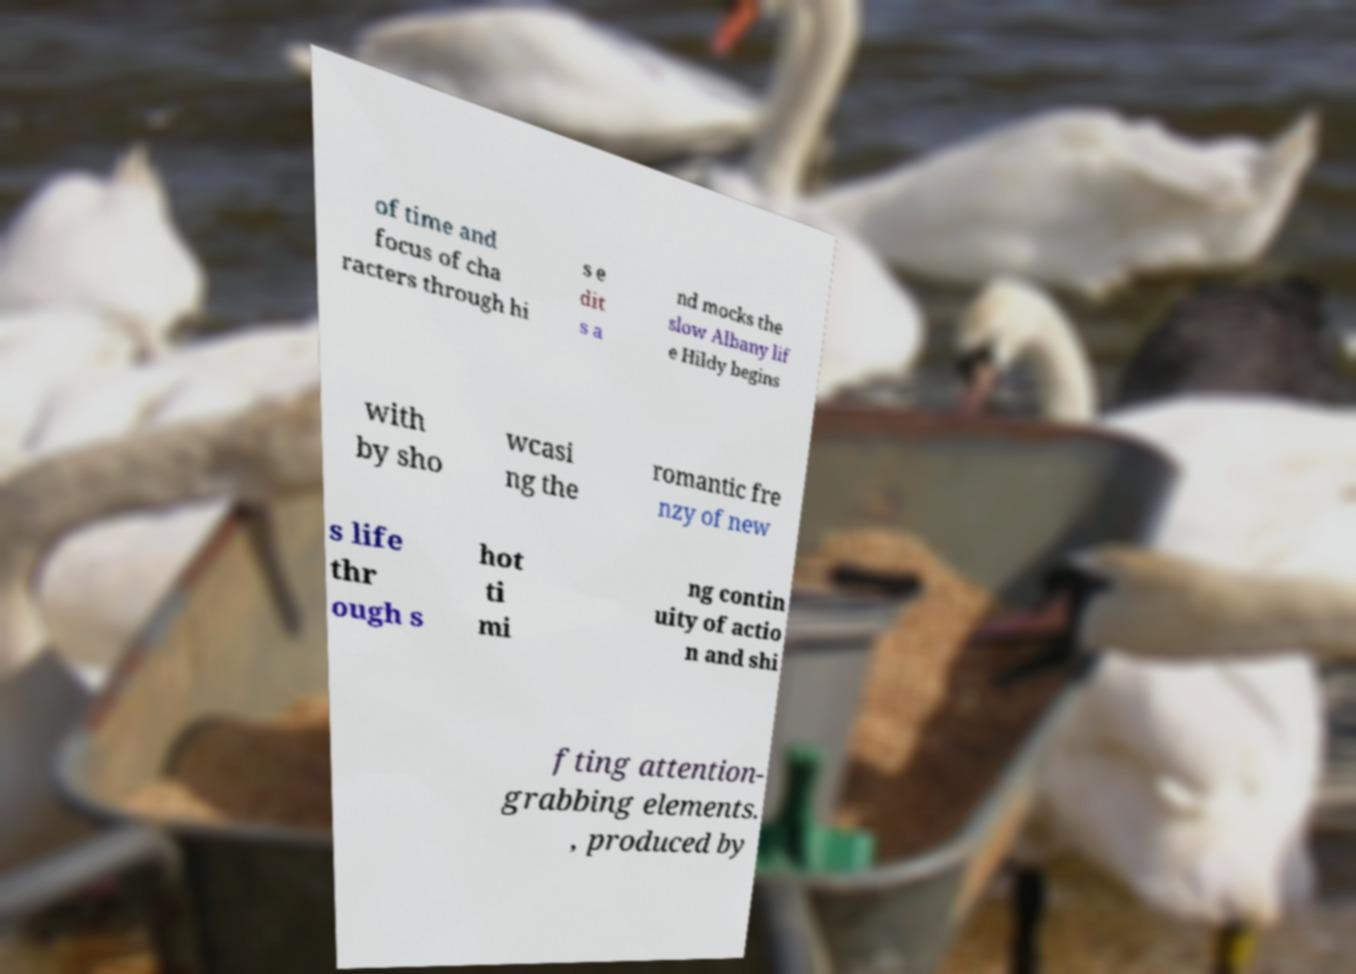Can you accurately transcribe the text from the provided image for me? of time and focus of cha racters through hi s e dit s a nd mocks the slow Albany lif e Hildy begins with by sho wcasi ng the romantic fre nzy of new s life thr ough s hot ti mi ng contin uity of actio n and shi fting attention- grabbing elements. , produced by 